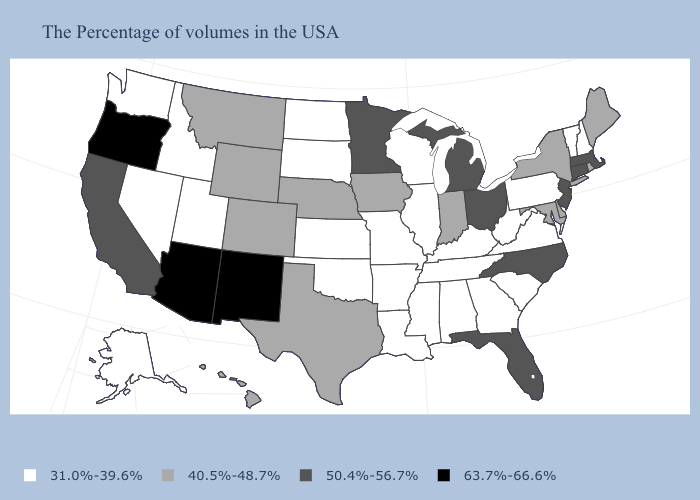What is the value of Nebraska?
Concise answer only. 40.5%-48.7%. Name the states that have a value in the range 63.7%-66.6%?
Short answer required. New Mexico, Arizona, Oregon. What is the value of West Virginia?
Keep it brief. 31.0%-39.6%. Does Missouri have the highest value in the MidWest?
Be succinct. No. Does Alabama have the same value as Florida?
Quick response, please. No. Name the states that have a value in the range 31.0%-39.6%?
Answer briefly. New Hampshire, Vermont, Pennsylvania, Virginia, South Carolina, West Virginia, Georgia, Kentucky, Alabama, Tennessee, Wisconsin, Illinois, Mississippi, Louisiana, Missouri, Arkansas, Kansas, Oklahoma, South Dakota, North Dakota, Utah, Idaho, Nevada, Washington, Alaska. Which states have the highest value in the USA?
Give a very brief answer. New Mexico, Arizona, Oregon. Does Kansas have the highest value in the MidWest?
Give a very brief answer. No. What is the value of Ohio?
Answer briefly. 50.4%-56.7%. Which states have the lowest value in the USA?
Be succinct. New Hampshire, Vermont, Pennsylvania, Virginia, South Carolina, West Virginia, Georgia, Kentucky, Alabama, Tennessee, Wisconsin, Illinois, Mississippi, Louisiana, Missouri, Arkansas, Kansas, Oklahoma, South Dakota, North Dakota, Utah, Idaho, Nevada, Washington, Alaska. Is the legend a continuous bar?
Give a very brief answer. No. What is the highest value in the West ?
Concise answer only. 63.7%-66.6%. Is the legend a continuous bar?
Keep it brief. No. What is the value of Maryland?
Concise answer only. 40.5%-48.7%. 